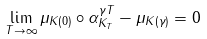Convert formula to latex. <formula><loc_0><loc_0><loc_500><loc_500>\lim _ { T \to \infty } \| \mu _ { K ( 0 ) } \circ \alpha _ { K _ { T } } ^ { \gamma T } - \mu _ { K ( \gamma ) } \| = 0</formula> 